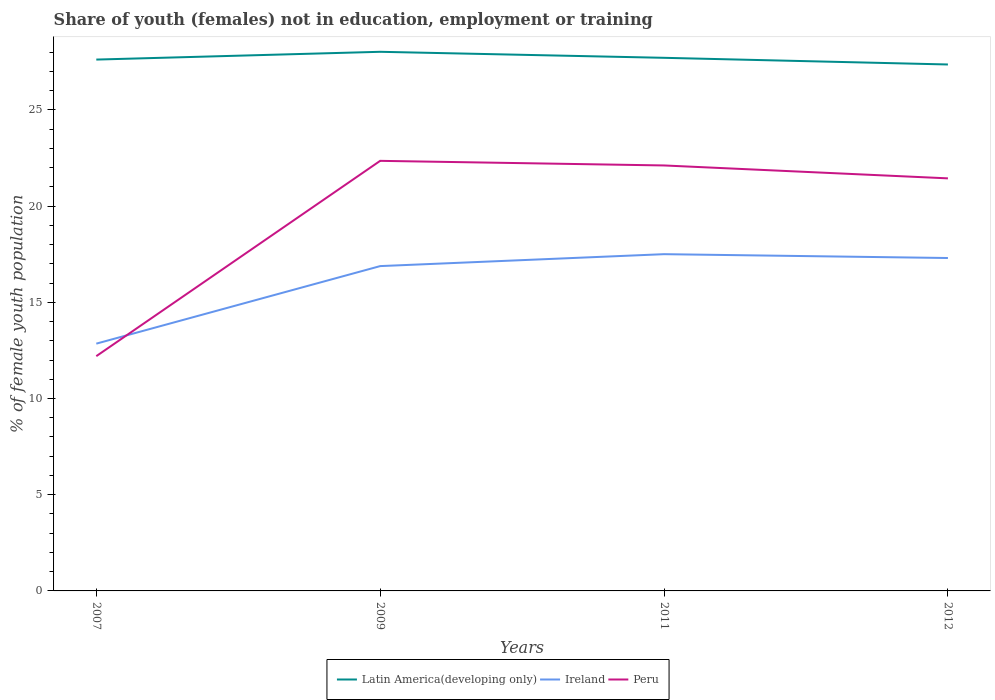Does the line corresponding to Peru intersect with the line corresponding to Latin America(developing only)?
Provide a succinct answer. No. Is the number of lines equal to the number of legend labels?
Ensure brevity in your answer.  Yes. Across all years, what is the maximum percentage of unemployed female population in in Ireland?
Keep it short and to the point. 12.85. What is the total percentage of unemployed female population in in Peru in the graph?
Provide a short and direct response. -9.24. What is the difference between the highest and the second highest percentage of unemployed female population in in Ireland?
Your answer should be very brief. 4.65. What is the difference between the highest and the lowest percentage of unemployed female population in in Ireland?
Your answer should be very brief. 3. Is the percentage of unemployed female population in in Peru strictly greater than the percentage of unemployed female population in in Ireland over the years?
Keep it short and to the point. No. How many lines are there?
Your answer should be very brief. 3. How many years are there in the graph?
Provide a succinct answer. 4. What is the difference between two consecutive major ticks on the Y-axis?
Ensure brevity in your answer.  5. Are the values on the major ticks of Y-axis written in scientific E-notation?
Provide a succinct answer. No. Does the graph contain any zero values?
Offer a terse response. No. Does the graph contain grids?
Ensure brevity in your answer.  No. How many legend labels are there?
Your answer should be very brief. 3. What is the title of the graph?
Offer a very short reply. Share of youth (females) not in education, employment or training. Does "Oman" appear as one of the legend labels in the graph?
Provide a short and direct response. No. What is the label or title of the Y-axis?
Give a very brief answer. % of female youth population. What is the % of female youth population of Latin America(developing only) in 2007?
Your answer should be compact. 27.61. What is the % of female youth population in Ireland in 2007?
Your response must be concise. 12.85. What is the % of female youth population of Peru in 2007?
Your answer should be compact. 12.2. What is the % of female youth population in Latin America(developing only) in 2009?
Give a very brief answer. 28.02. What is the % of female youth population of Ireland in 2009?
Your response must be concise. 16.88. What is the % of female youth population of Peru in 2009?
Offer a terse response. 22.35. What is the % of female youth population in Latin America(developing only) in 2011?
Ensure brevity in your answer.  27.7. What is the % of female youth population in Peru in 2011?
Your answer should be compact. 22.11. What is the % of female youth population in Latin America(developing only) in 2012?
Provide a short and direct response. 27.36. What is the % of female youth population of Ireland in 2012?
Make the answer very short. 17.3. What is the % of female youth population in Peru in 2012?
Keep it short and to the point. 21.44. Across all years, what is the maximum % of female youth population in Latin America(developing only)?
Provide a short and direct response. 28.02. Across all years, what is the maximum % of female youth population in Ireland?
Your answer should be very brief. 17.5. Across all years, what is the maximum % of female youth population in Peru?
Give a very brief answer. 22.35. Across all years, what is the minimum % of female youth population in Latin America(developing only)?
Provide a short and direct response. 27.36. Across all years, what is the minimum % of female youth population in Ireland?
Provide a short and direct response. 12.85. Across all years, what is the minimum % of female youth population of Peru?
Give a very brief answer. 12.2. What is the total % of female youth population of Latin America(developing only) in the graph?
Your answer should be compact. 110.69. What is the total % of female youth population in Ireland in the graph?
Provide a succinct answer. 64.53. What is the total % of female youth population in Peru in the graph?
Keep it short and to the point. 78.1. What is the difference between the % of female youth population of Latin America(developing only) in 2007 and that in 2009?
Make the answer very short. -0.4. What is the difference between the % of female youth population in Ireland in 2007 and that in 2009?
Provide a short and direct response. -4.03. What is the difference between the % of female youth population in Peru in 2007 and that in 2009?
Provide a short and direct response. -10.15. What is the difference between the % of female youth population in Latin America(developing only) in 2007 and that in 2011?
Give a very brief answer. -0.09. What is the difference between the % of female youth population of Ireland in 2007 and that in 2011?
Provide a succinct answer. -4.65. What is the difference between the % of female youth population in Peru in 2007 and that in 2011?
Ensure brevity in your answer.  -9.91. What is the difference between the % of female youth population of Latin America(developing only) in 2007 and that in 2012?
Give a very brief answer. 0.25. What is the difference between the % of female youth population of Ireland in 2007 and that in 2012?
Offer a very short reply. -4.45. What is the difference between the % of female youth population of Peru in 2007 and that in 2012?
Provide a succinct answer. -9.24. What is the difference between the % of female youth population in Latin America(developing only) in 2009 and that in 2011?
Provide a short and direct response. 0.31. What is the difference between the % of female youth population in Ireland in 2009 and that in 2011?
Provide a succinct answer. -0.62. What is the difference between the % of female youth population in Peru in 2009 and that in 2011?
Your answer should be compact. 0.24. What is the difference between the % of female youth population of Latin America(developing only) in 2009 and that in 2012?
Make the answer very short. 0.66. What is the difference between the % of female youth population of Ireland in 2009 and that in 2012?
Keep it short and to the point. -0.42. What is the difference between the % of female youth population of Peru in 2009 and that in 2012?
Provide a succinct answer. 0.91. What is the difference between the % of female youth population of Latin America(developing only) in 2011 and that in 2012?
Give a very brief answer. 0.35. What is the difference between the % of female youth population of Ireland in 2011 and that in 2012?
Keep it short and to the point. 0.2. What is the difference between the % of female youth population in Peru in 2011 and that in 2012?
Offer a very short reply. 0.67. What is the difference between the % of female youth population in Latin America(developing only) in 2007 and the % of female youth population in Ireland in 2009?
Make the answer very short. 10.73. What is the difference between the % of female youth population in Latin America(developing only) in 2007 and the % of female youth population in Peru in 2009?
Your answer should be very brief. 5.26. What is the difference between the % of female youth population of Latin America(developing only) in 2007 and the % of female youth population of Ireland in 2011?
Your answer should be compact. 10.11. What is the difference between the % of female youth population in Latin America(developing only) in 2007 and the % of female youth population in Peru in 2011?
Ensure brevity in your answer.  5.5. What is the difference between the % of female youth population of Ireland in 2007 and the % of female youth population of Peru in 2011?
Your answer should be very brief. -9.26. What is the difference between the % of female youth population in Latin America(developing only) in 2007 and the % of female youth population in Ireland in 2012?
Your response must be concise. 10.31. What is the difference between the % of female youth population of Latin America(developing only) in 2007 and the % of female youth population of Peru in 2012?
Offer a very short reply. 6.17. What is the difference between the % of female youth population in Ireland in 2007 and the % of female youth population in Peru in 2012?
Your answer should be compact. -8.59. What is the difference between the % of female youth population in Latin America(developing only) in 2009 and the % of female youth population in Ireland in 2011?
Offer a very short reply. 10.52. What is the difference between the % of female youth population of Latin America(developing only) in 2009 and the % of female youth population of Peru in 2011?
Your response must be concise. 5.91. What is the difference between the % of female youth population in Ireland in 2009 and the % of female youth population in Peru in 2011?
Give a very brief answer. -5.23. What is the difference between the % of female youth population in Latin America(developing only) in 2009 and the % of female youth population in Ireland in 2012?
Your answer should be very brief. 10.72. What is the difference between the % of female youth population of Latin America(developing only) in 2009 and the % of female youth population of Peru in 2012?
Provide a succinct answer. 6.58. What is the difference between the % of female youth population in Ireland in 2009 and the % of female youth population in Peru in 2012?
Provide a succinct answer. -4.56. What is the difference between the % of female youth population of Latin America(developing only) in 2011 and the % of female youth population of Ireland in 2012?
Give a very brief answer. 10.4. What is the difference between the % of female youth population in Latin America(developing only) in 2011 and the % of female youth population in Peru in 2012?
Keep it short and to the point. 6.26. What is the difference between the % of female youth population in Ireland in 2011 and the % of female youth population in Peru in 2012?
Ensure brevity in your answer.  -3.94. What is the average % of female youth population of Latin America(developing only) per year?
Give a very brief answer. 27.67. What is the average % of female youth population in Ireland per year?
Ensure brevity in your answer.  16.13. What is the average % of female youth population of Peru per year?
Provide a succinct answer. 19.52. In the year 2007, what is the difference between the % of female youth population in Latin America(developing only) and % of female youth population in Ireland?
Your answer should be compact. 14.76. In the year 2007, what is the difference between the % of female youth population in Latin America(developing only) and % of female youth population in Peru?
Offer a terse response. 15.41. In the year 2007, what is the difference between the % of female youth population of Ireland and % of female youth population of Peru?
Provide a succinct answer. 0.65. In the year 2009, what is the difference between the % of female youth population of Latin America(developing only) and % of female youth population of Ireland?
Ensure brevity in your answer.  11.14. In the year 2009, what is the difference between the % of female youth population of Latin America(developing only) and % of female youth population of Peru?
Make the answer very short. 5.67. In the year 2009, what is the difference between the % of female youth population of Ireland and % of female youth population of Peru?
Provide a succinct answer. -5.47. In the year 2011, what is the difference between the % of female youth population in Latin America(developing only) and % of female youth population in Ireland?
Your answer should be very brief. 10.2. In the year 2011, what is the difference between the % of female youth population in Latin America(developing only) and % of female youth population in Peru?
Give a very brief answer. 5.59. In the year 2011, what is the difference between the % of female youth population of Ireland and % of female youth population of Peru?
Make the answer very short. -4.61. In the year 2012, what is the difference between the % of female youth population in Latin America(developing only) and % of female youth population in Ireland?
Your response must be concise. 10.06. In the year 2012, what is the difference between the % of female youth population of Latin America(developing only) and % of female youth population of Peru?
Give a very brief answer. 5.92. In the year 2012, what is the difference between the % of female youth population of Ireland and % of female youth population of Peru?
Offer a terse response. -4.14. What is the ratio of the % of female youth population in Latin America(developing only) in 2007 to that in 2009?
Make the answer very short. 0.99. What is the ratio of the % of female youth population in Ireland in 2007 to that in 2009?
Your response must be concise. 0.76. What is the ratio of the % of female youth population in Peru in 2007 to that in 2009?
Provide a short and direct response. 0.55. What is the ratio of the % of female youth population in Latin America(developing only) in 2007 to that in 2011?
Offer a very short reply. 1. What is the ratio of the % of female youth population of Ireland in 2007 to that in 2011?
Your answer should be compact. 0.73. What is the ratio of the % of female youth population of Peru in 2007 to that in 2011?
Ensure brevity in your answer.  0.55. What is the ratio of the % of female youth population of Latin America(developing only) in 2007 to that in 2012?
Provide a short and direct response. 1.01. What is the ratio of the % of female youth population in Ireland in 2007 to that in 2012?
Offer a terse response. 0.74. What is the ratio of the % of female youth population in Peru in 2007 to that in 2012?
Offer a very short reply. 0.57. What is the ratio of the % of female youth population of Latin America(developing only) in 2009 to that in 2011?
Give a very brief answer. 1.01. What is the ratio of the % of female youth population in Ireland in 2009 to that in 2011?
Your answer should be compact. 0.96. What is the ratio of the % of female youth population of Peru in 2009 to that in 2011?
Provide a short and direct response. 1.01. What is the ratio of the % of female youth population in Latin America(developing only) in 2009 to that in 2012?
Your answer should be very brief. 1.02. What is the ratio of the % of female youth population in Ireland in 2009 to that in 2012?
Ensure brevity in your answer.  0.98. What is the ratio of the % of female youth population in Peru in 2009 to that in 2012?
Ensure brevity in your answer.  1.04. What is the ratio of the % of female youth population in Latin America(developing only) in 2011 to that in 2012?
Ensure brevity in your answer.  1.01. What is the ratio of the % of female youth population in Ireland in 2011 to that in 2012?
Offer a very short reply. 1.01. What is the ratio of the % of female youth population of Peru in 2011 to that in 2012?
Offer a terse response. 1.03. What is the difference between the highest and the second highest % of female youth population of Latin America(developing only)?
Your response must be concise. 0.31. What is the difference between the highest and the second highest % of female youth population of Peru?
Your answer should be very brief. 0.24. What is the difference between the highest and the lowest % of female youth population of Latin America(developing only)?
Your response must be concise. 0.66. What is the difference between the highest and the lowest % of female youth population in Ireland?
Make the answer very short. 4.65. What is the difference between the highest and the lowest % of female youth population in Peru?
Make the answer very short. 10.15. 